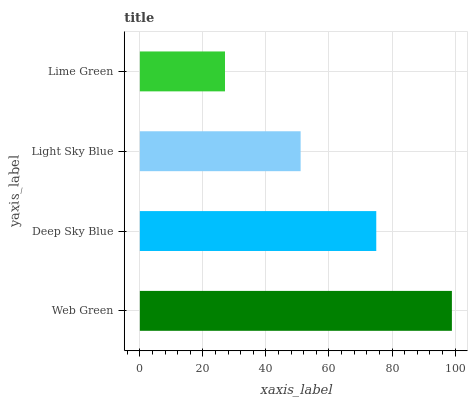Is Lime Green the minimum?
Answer yes or no. Yes. Is Web Green the maximum?
Answer yes or no. Yes. Is Deep Sky Blue the minimum?
Answer yes or no. No. Is Deep Sky Blue the maximum?
Answer yes or no. No. Is Web Green greater than Deep Sky Blue?
Answer yes or no. Yes. Is Deep Sky Blue less than Web Green?
Answer yes or no. Yes. Is Deep Sky Blue greater than Web Green?
Answer yes or no. No. Is Web Green less than Deep Sky Blue?
Answer yes or no. No. Is Deep Sky Blue the high median?
Answer yes or no. Yes. Is Light Sky Blue the low median?
Answer yes or no. Yes. Is Lime Green the high median?
Answer yes or no. No. Is Deep Sky Blue the low median?
Answer yes or no. No. 